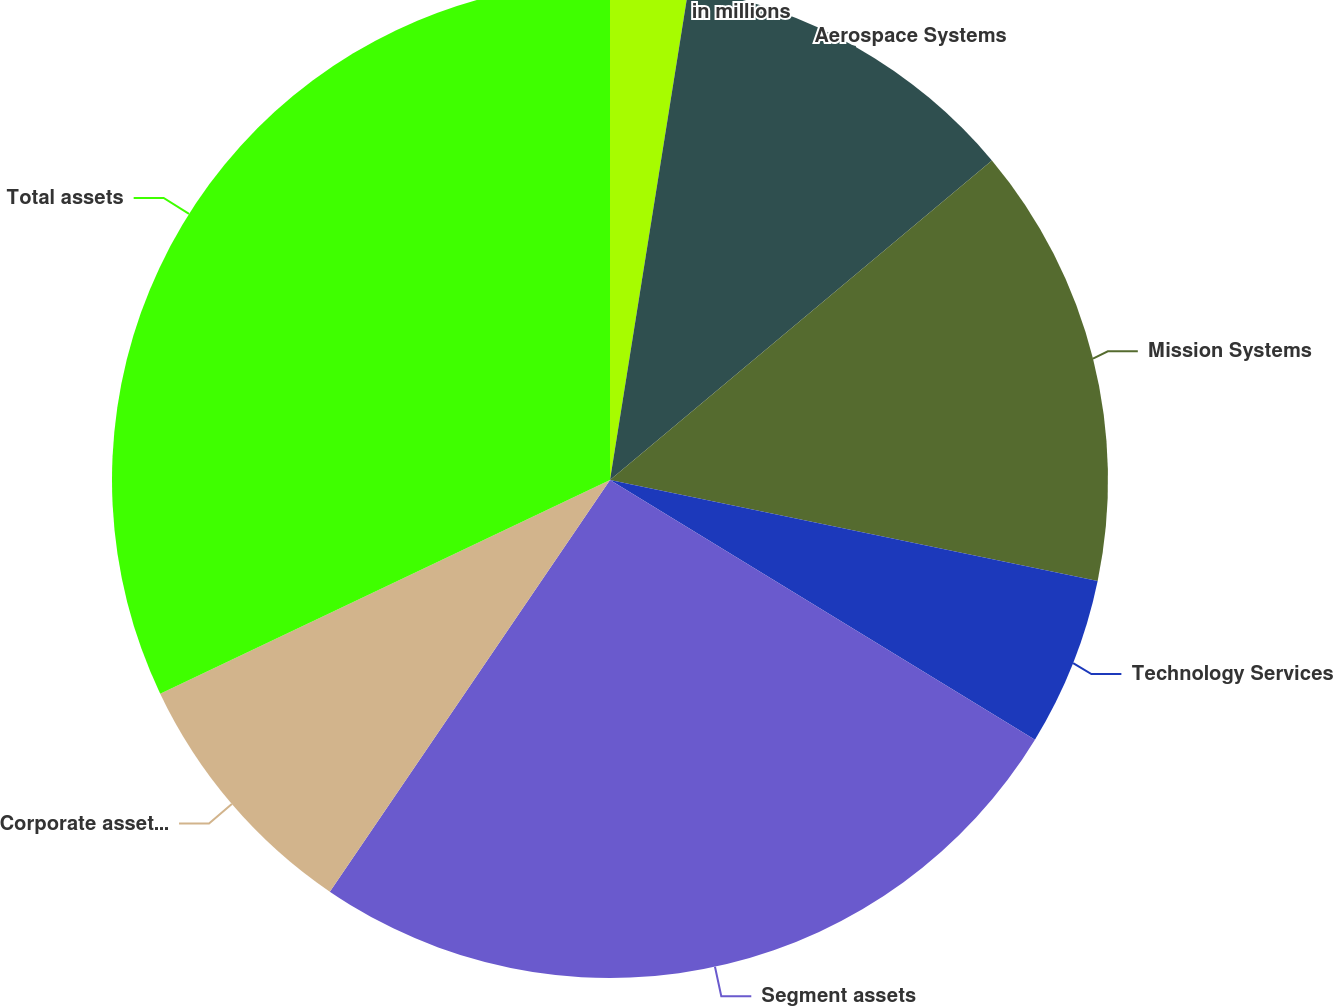<chart> <loc_0><loc_0><loc_500><loc_500><pie_chart><fcel>in millions<fcel>Aerospace Systems<fcel>Mission Systems<fcel>Technology Services<fcel>Segment assets<fcel>Corporate assets (1)<fcel>Total assets<nl><fcel>2.52%<fcel>11.39%<fcel>14.34%<fcel>5.48%<fcel>25.78%<fcel>8.43%<fcel>32.06%<nl></chart> 